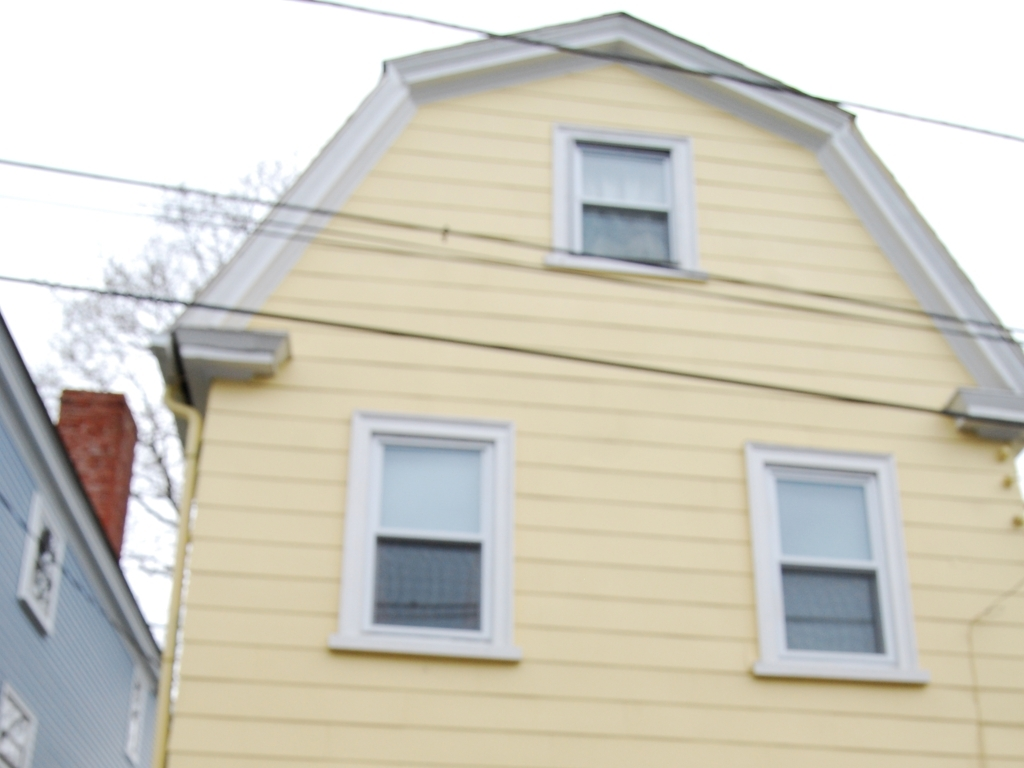Does the house appear to be in a residential area? Yes, the house is situated in a residential area. You can spot other houses in close proximity, which indicates a neighborhood setting. Is it common for houses in this area to be so close to each other? In many urban and suburban areas, it is quite common to find houses built near to one another to efficiently use space and accommodate more residents within a limited area. 